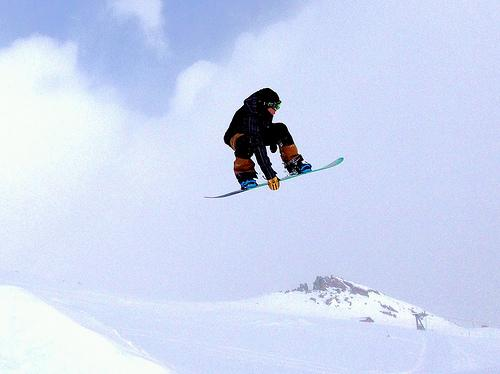Provide a brief description of the primary figure participating in an activity in the photograph. The image depicts a snowboarder, in a black ski suit and wearing goggles, soaring through the air while doing a stunt. Explain the notable interaction between a person and their environment in the image. A person wearing a black ski suit launches off a snowy mountain slope, achieving remarkable airtime while performing a snowboarding trick. In a concise manner, outline the primary subject and their action in the image. A snowboarder wearing a black jacket is catching some serious air while executing a high-flying move. Mention the central action portrayed in the image and its main character. A snowboarder is performing an impressive trick in mid-air. In one sentence, explain what the most significant event in the image is. A person on a blue snowboard is skillfully executing a jump high above a snowy mountain. Summarize the key occurrence in the image involving a person. A daring snowboarder is leaping off a snow-covered mountain, performing a captivating maneuver in the process. Discuss the main event taking place in the image, specifically mentioning what one person is doing. In the photograph, a snowboarder sporting a blue snowboard and ski goggles is seen soaring through the sky while doing a trick. Describe in one sentence the main focus of the photo and the action that the person is engaged in. In the image, a snowboarder rocking a blue snowboard and black ski suit is captured mid-jump, performing an incredible stunt. Give a brief account of the central figure in the picture and what they are accomplishing. An individual with a black hat and ski goggles is impressively airborne, tackling a difficult snowboarding stunt with finesse. Describe the principal individual in the scene and their ongoing activity. A snowboarder, complete with black ski attire and a yellow glove, is caught in the middle of an electrifying stunt in the air. 